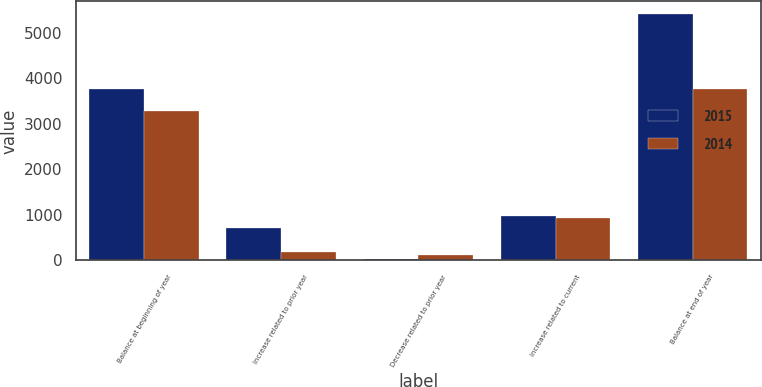<chart> <loc_0><loc_0><loc_500><loc_500><stacked_bar_chart><ecel><fcel>Balance at beginning of year<fcel>Increase related to prior year<fcel>Decrease related to prior year<fcel>Increase related to current<fcel>Balance at end of year<nl><fcel>2015<fcel>3772<fcel>704<fcel>43<fcel>984<fcel>5417<nl><fcel>2014<fcel>3282<fcel>185<fcel>113<fcel>924<fcel>3772<nl></chart> 